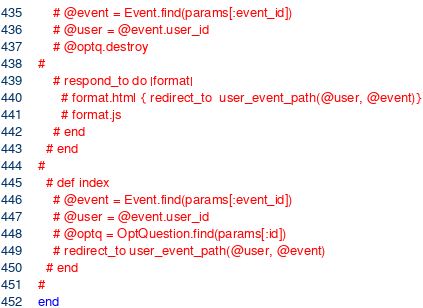Convert code to text. <code><loc_0><loc_0><loc_500><loc_500><_Ruby_>    # @event = Event.find(params[:event_id])
    # @user = @event.user_id
    # @optq.destroy
#     
    # respond_to do |format|
      # format.html { redirect_to  user_event_path(@user, @event)}
      # format.js
    # end
  # end
#   
  # def index
    # @event = Event.find(params[:event_id])
    # @user = @event.user_id
    # @optq = OptQuestion.find(params[:id])
    # redirect_to user_event_path(@user, @event)
  # end
#   
end
</code> 